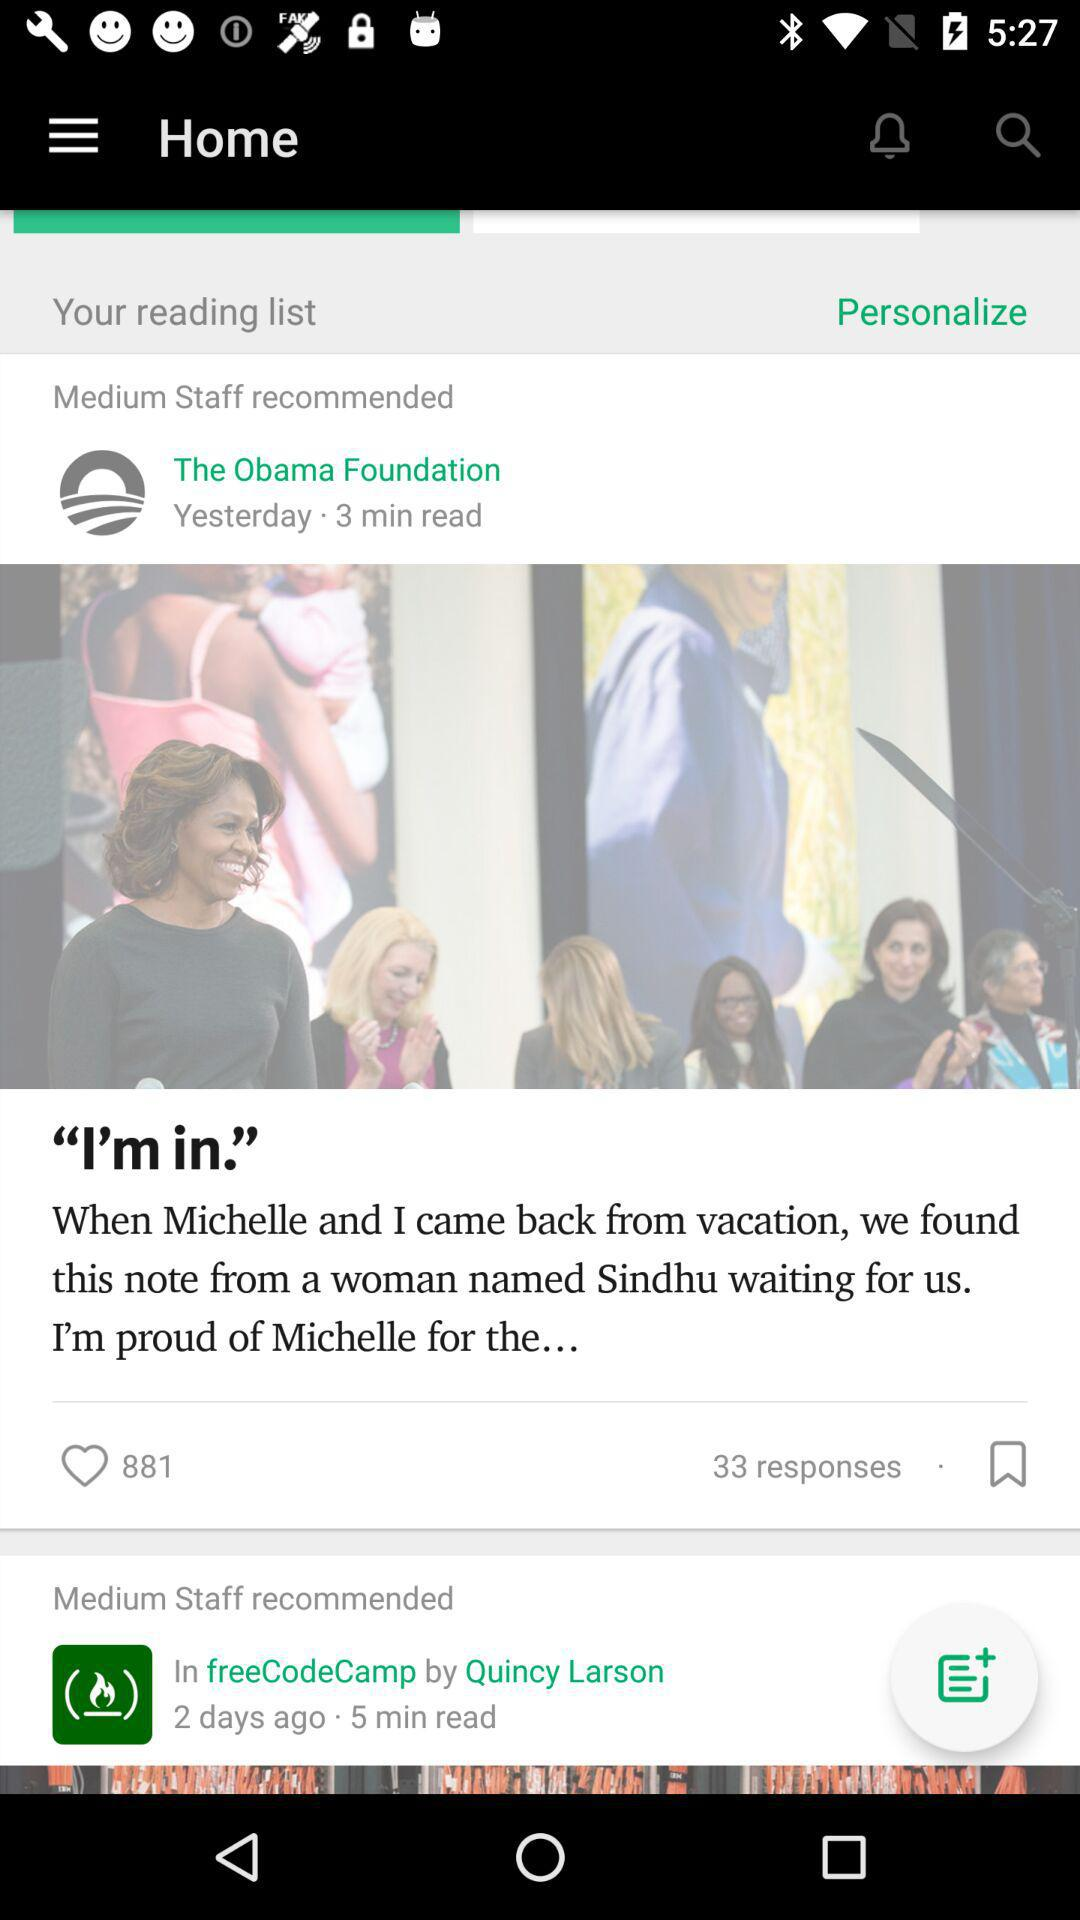How many more minutes did the first article take to read than the second?
Answer the question using a single word or phrase. 2 